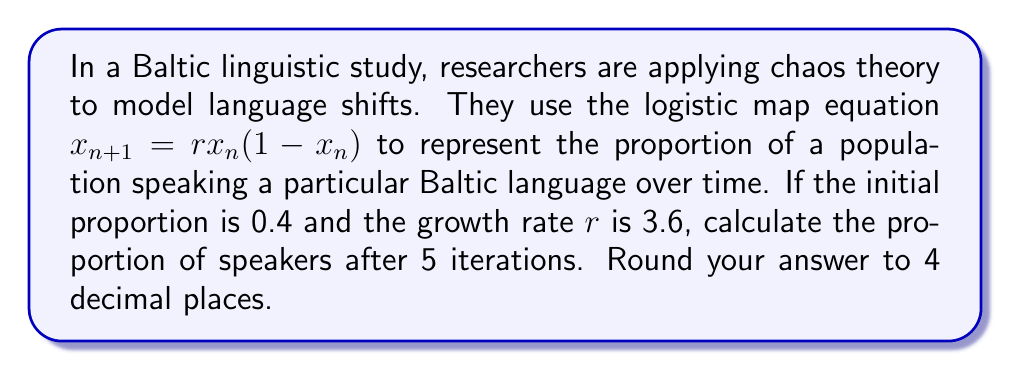Solve this math problem. To solve this problem, we'll use the logistic map equation iteratively:

$$x_{n+1} = rx_n(1-x_n)$$

Given:
- Initial proportion $x_0 = 0.4$
- Growth rate $r = 3.6$
- Number of iterations = 5

Let's calculate step by step:

1) First iteration:
   $x_1 = 3.6 \cdot 0.4 \cdot (1-0.4) = 3.6 \cdot 0.4 \cdot 0.6 = 0.864$

2) Second iteration:
   $x_2 = 3.6 \cdot 0.864 \cdot (1-0.864) = 3.6 \cdot 0.864 \cdot 0.136 = 0.4233216$

3) Third iteration:
   $x_3 = 3.6 \cdot 0.4233216 \cdot (1-0.4233216) = 0.8784603$

4) Fourth iteration:
   $x_4 = 3.6 \cdot 0.8784603 \cdot (1-0.8784603) = 0.3845255$

5) Fifth iteration:
   $x_5 = 3.6 \cdot 0.3845255 \cdot (1-0.3845255) = 0.8546604$

Rounding to 4 decimal places: 0.8547
Answer: 0.8547 